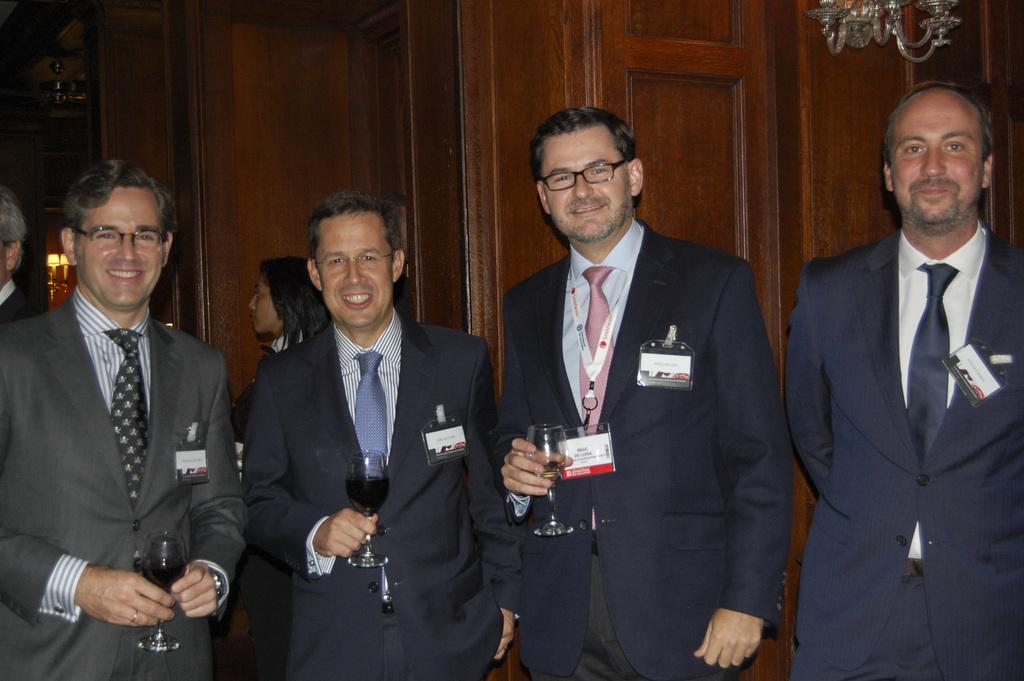What is the main subject of the image? There is a man standing in the middle of the image. Can you describe the man's attire? The man is wearing a coat and a tie shirt. What is the man holding in his right hand? The man is holding a wine glass in his right hand. Are there any other people in the image? Yes, there are other men standing near the man. What can be seen in the background of the image? There is a door visible in the background of the image. What type of fork is the man using to eat his meal in the image? There is no fork present in the image; the man is holding a wine glass. What is the cause of death for the man in the image? There is no indication of death in the image; the man is standing and holding a wine glass. 